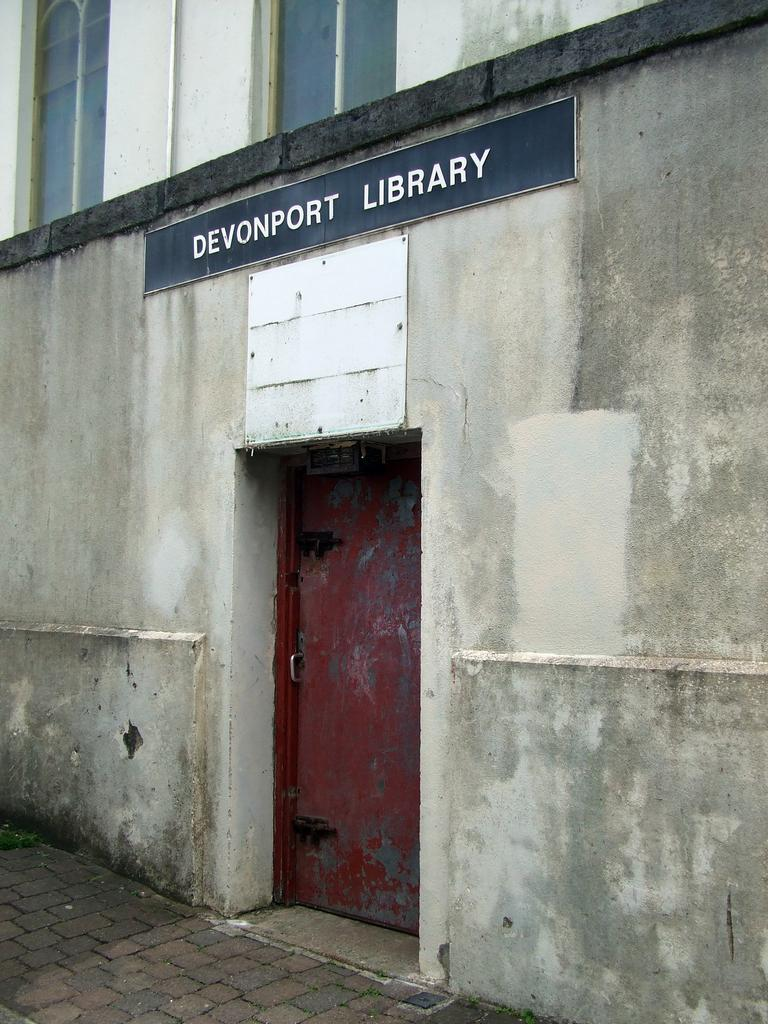What is the main structure in the image? There is a building in the middle of the image. Where is the entrance to the building located? There is a door at the bottom of the building. What can be seen at the top of the building? There are windows at the top of the building. Is there any additional information displayed on the building? Yes, there is a board attached to the wall of the building. What type of memory is stored in the building in the image? There is no indication of any memory being stored in the building in the image. 